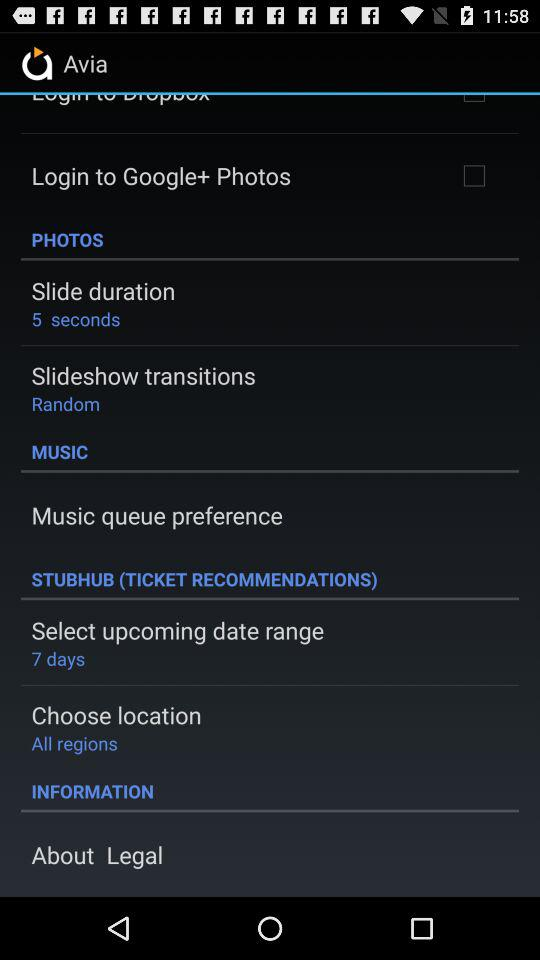What is the slide duration? The slide duration is 5 seconds. 